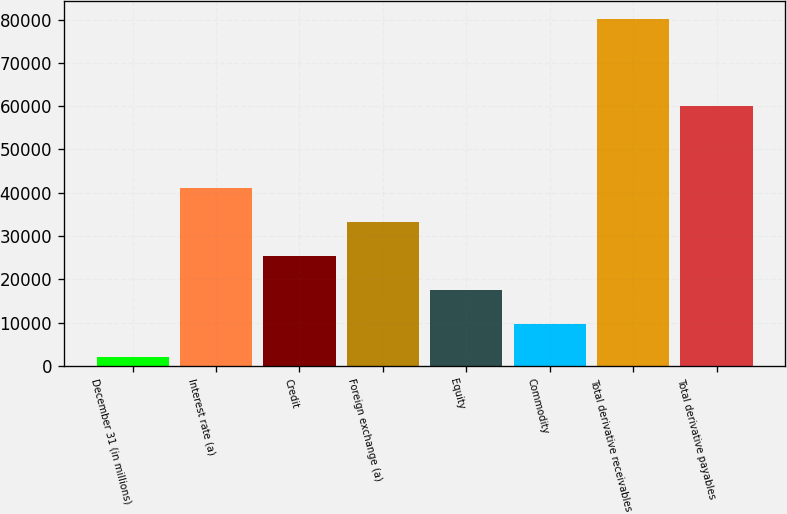Convert chart to OTSL. <chart><loc_0><loc_0><loc_500><loc_500><bar_chart><fcel>December 31 (in millions)<fcel>Interest rate (a)<fcel>Credit<fcel>Foreign exchange (a)<fcel>Equity<fcel>Commodity<fcel>Total derivative receivables<fcel>Total derivative payables<nl><fcel>2009<fcel>41109.5<fcel>25469.3<fcel>33289.4<fcel>17649.2<fcel>9829.1<fcel>80210<fcel>60125<nl></chart> 